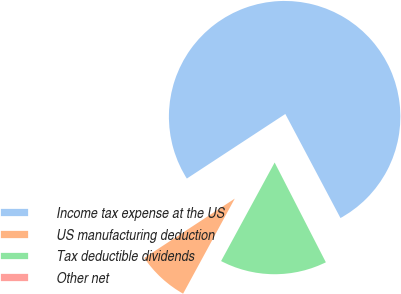Convert chart to OTSL. <chart><loc_0><loc_0><loc_500><loc_500><pie_chart><fcel>Income tax expense at the US<fcel>US manufacturing deduction<fcel>Tax deductible dividends<fcel>Other net<nl><fcel>76.48%<fcel>7.84%<fcel>15.47%<fcel>0.21%<nl></chart> 